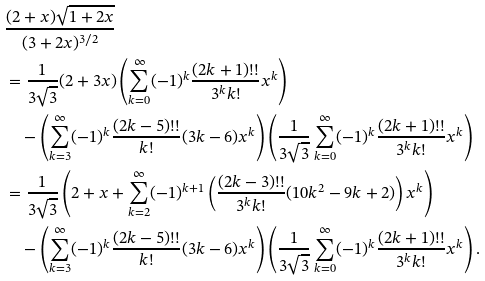Convert formula to latex. <formula><loc_0><loc_0><loc_500><loc_500>& \frac { ( 2 + x ) \sqrt { 1 + 2 x } } { ( 3 + 2 x ) ^ { 3 / 2 } } \\ & = \frac { 1 } { 3 \sqrt { 3 } } ( 2 + 3 x ) \left ( \sum _ { k = 0 } ^ { \infty } ( - 1 ) ^ { k } \frac { ( 2 k + 1 ) ! ! } { 3 ^ { k } k ! } x ^ { k } \right ) \\ & \quad - \left ( \sum _ { k = 3 } ^ { \infty } ( - 1 ) ^ { k } \frac { ( 2 k - 5 ) ! ! } { k ! } ( 3 k - 6 ) x ^ { k } \right ) \left ( \frac { 1 } { 3 \sqrt { 3 } } \sum _ { k = 0 } ^ { \infty } ( - 1 ) ^ { k } \frac { ( 2 k + 1 ) ! ! } { 3 ^ { k } k ! } x ^ { k } \right ) \\ & = \frac { 1 } { 3 \sqrt { 3 } } \left ( 2 + x + \sum _ { k = 2 } ^ { \infty } ( - 1 ) ^ { k + 1 } \left ( \frac { ( 2 k - 3 ) ! ! } { 3 ^ { k } k ! } ( 1 0 k ^ { 2 } - 9 k + 2 ) \right ) x ^ { k } \right ) \\ & \quad - \left ( \sum _ { k = 3 } ^ { \infty } ( - 1 ) ^ { k } \frac { ( 2 k - 5 ) ! ! } { k ! } ( 3 k - 6 ) x ^ { k } \right ) \left ( \frac { 1 } { 3 \sqrt { 3 } } \sum _ { k = 0 } ^ { \infty } ( - 1 ) ^ { k } \frac { ( 2 k + 1 ) ! ! } { 3 ^ { k } k ! } x ^ { k } \right ) .</formula> 